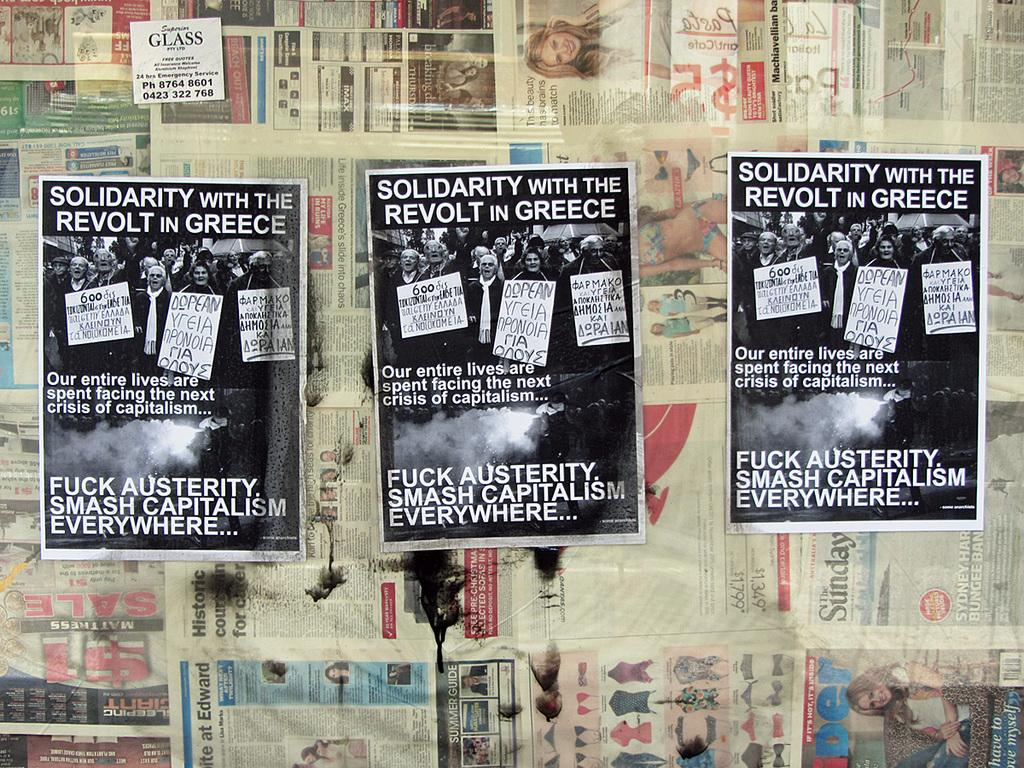<image>
Present a compact description of the photo's key features. a poster that says to smash capitalism everywhere 